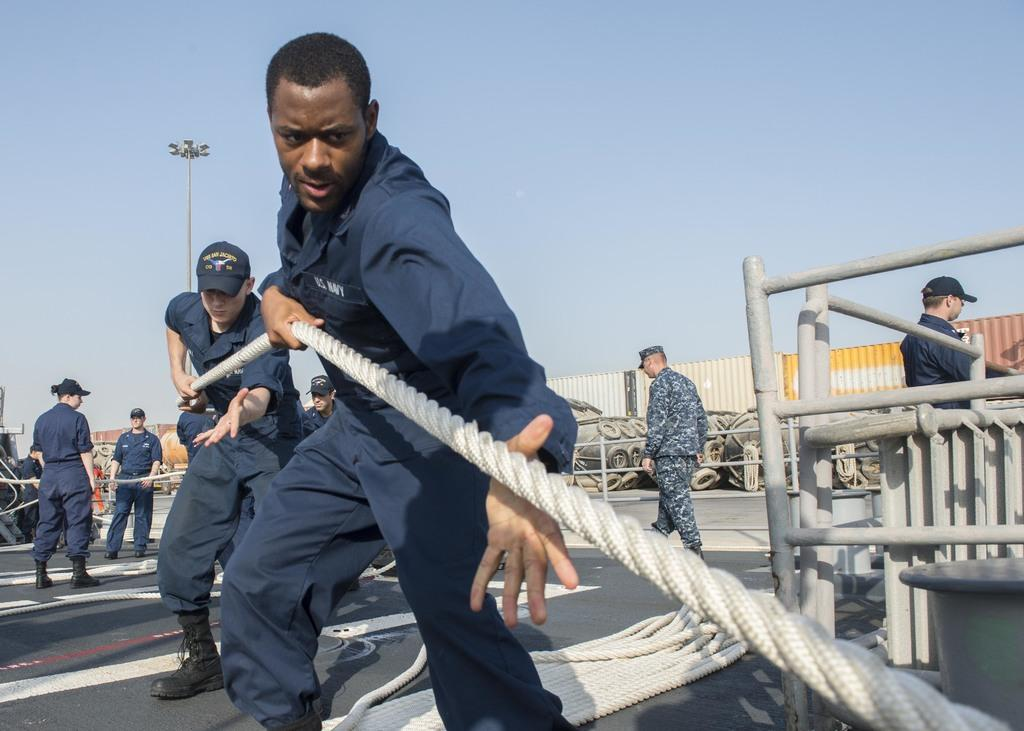Who or what is present in the image? There are people in the image. What are the people doing in the image? The people are pulling a rope. What can be seen in the background of the image? There are containers and other objects present in the background of the image. What type of pancake is being served at the party in the image? There is no party or pancake present in the image; it features people pulling a rope with containers and other objects in the background. 